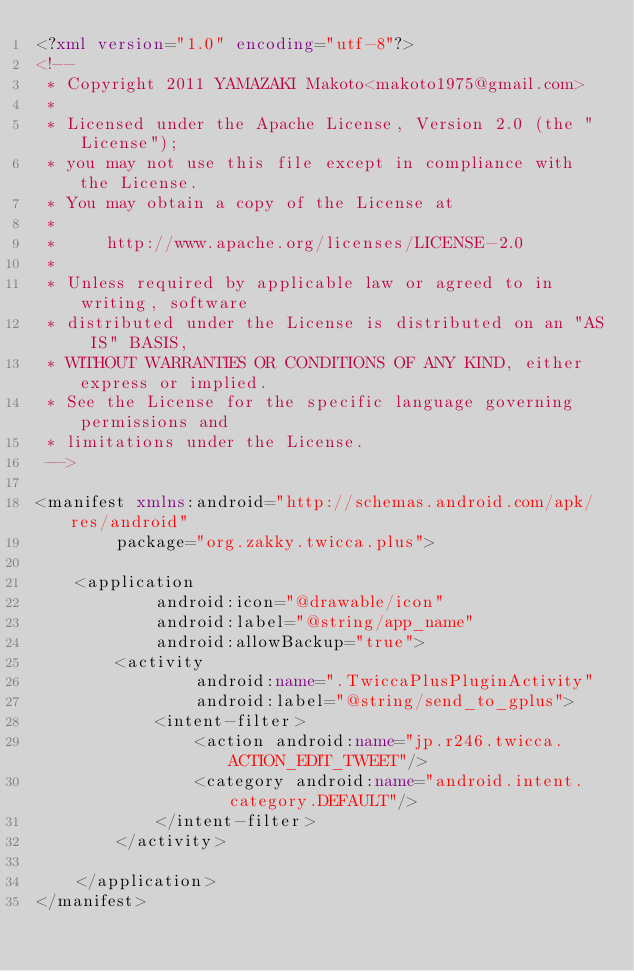Convert code to text. <code><loc_0><loc_0><loc_500><loc_500><_XML_><?xml version="1.0" encoding="utf-8"?>
<!--
 * Copyright 2011 YAMAZAKI Makoto<makoto1975@gmail.com>
 *
 * Licensed under the Apache License, Version 2.0 (the "License");
 * you may not use this file except in compliance with the License.
 * You may obtain a copy of the License at
 *
 *     http://www.apache.org/licenses/LICENSE-2.0
 *
 * Unless required by applicable law or agreed to in writing, software
 * distributed under the License is distributed on an "AS IS" BASIS,
 * WITHOUT WARRANTIES OR CONDITIONS OF ANY KIND, either express or implied.
 * See the License for the specific language governing permissions and
 * limitations under the License.
 -->

<manifest xmlns:android="http://schemas.android.com/apk/res/android"
        package="org.zakky.twicca.plus">

    <application
            android:icon="@drawable/icon"
            android:label="@string/app_name"
            android:allowBackup="true">
        <activity
                android:name=".TwiccaPlusPluginActivity"
                android:label="@string/send_to_gplus">
            <intent-filter>
                <action android:name="jp.r246.twicca.ACTION_EDIT_TWEET"/>
                <category android:name="android.intent.category.DEFAULT"/>
            </intent-filter>
        </activity>

    </application>
</manifest>
</code> 